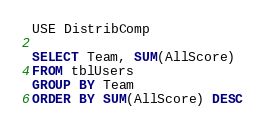<code> <loc_0><loc_0><loc_500><loc_500><_SQL_>USE DistribComp

SELECT Team, SUM(AllScore)
FROM tblUsers
GROUP BY Team
ORDER BY SUM(AllScore) DESC</code> 